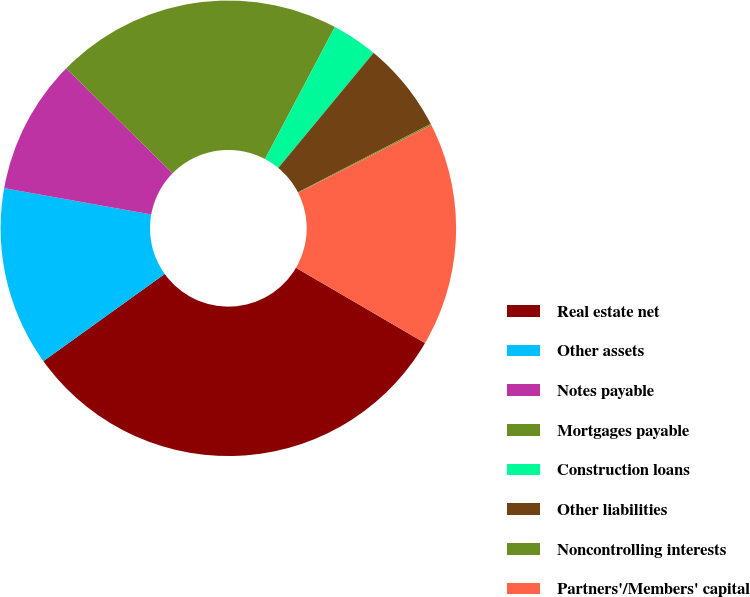<chart> <loc_0><loc_0><loc_500><loc_500><pie_chart><fcel>Real estate net<fcel>Other assets<fcel>Notes payable<fcel>Mortgages payable<fcel>Construction loans<fcel>Other liabilities<fcel>Noncontrolling interests<fcel>Partners'/Members' capital<nl><fcel>31.68%<fcel>12.73%<fcel>9.57%<fcel>20.36%<fcel>3.26%<fcel>6.41%<fcel>0.1%<fcel>15.89%<nl></chart> 